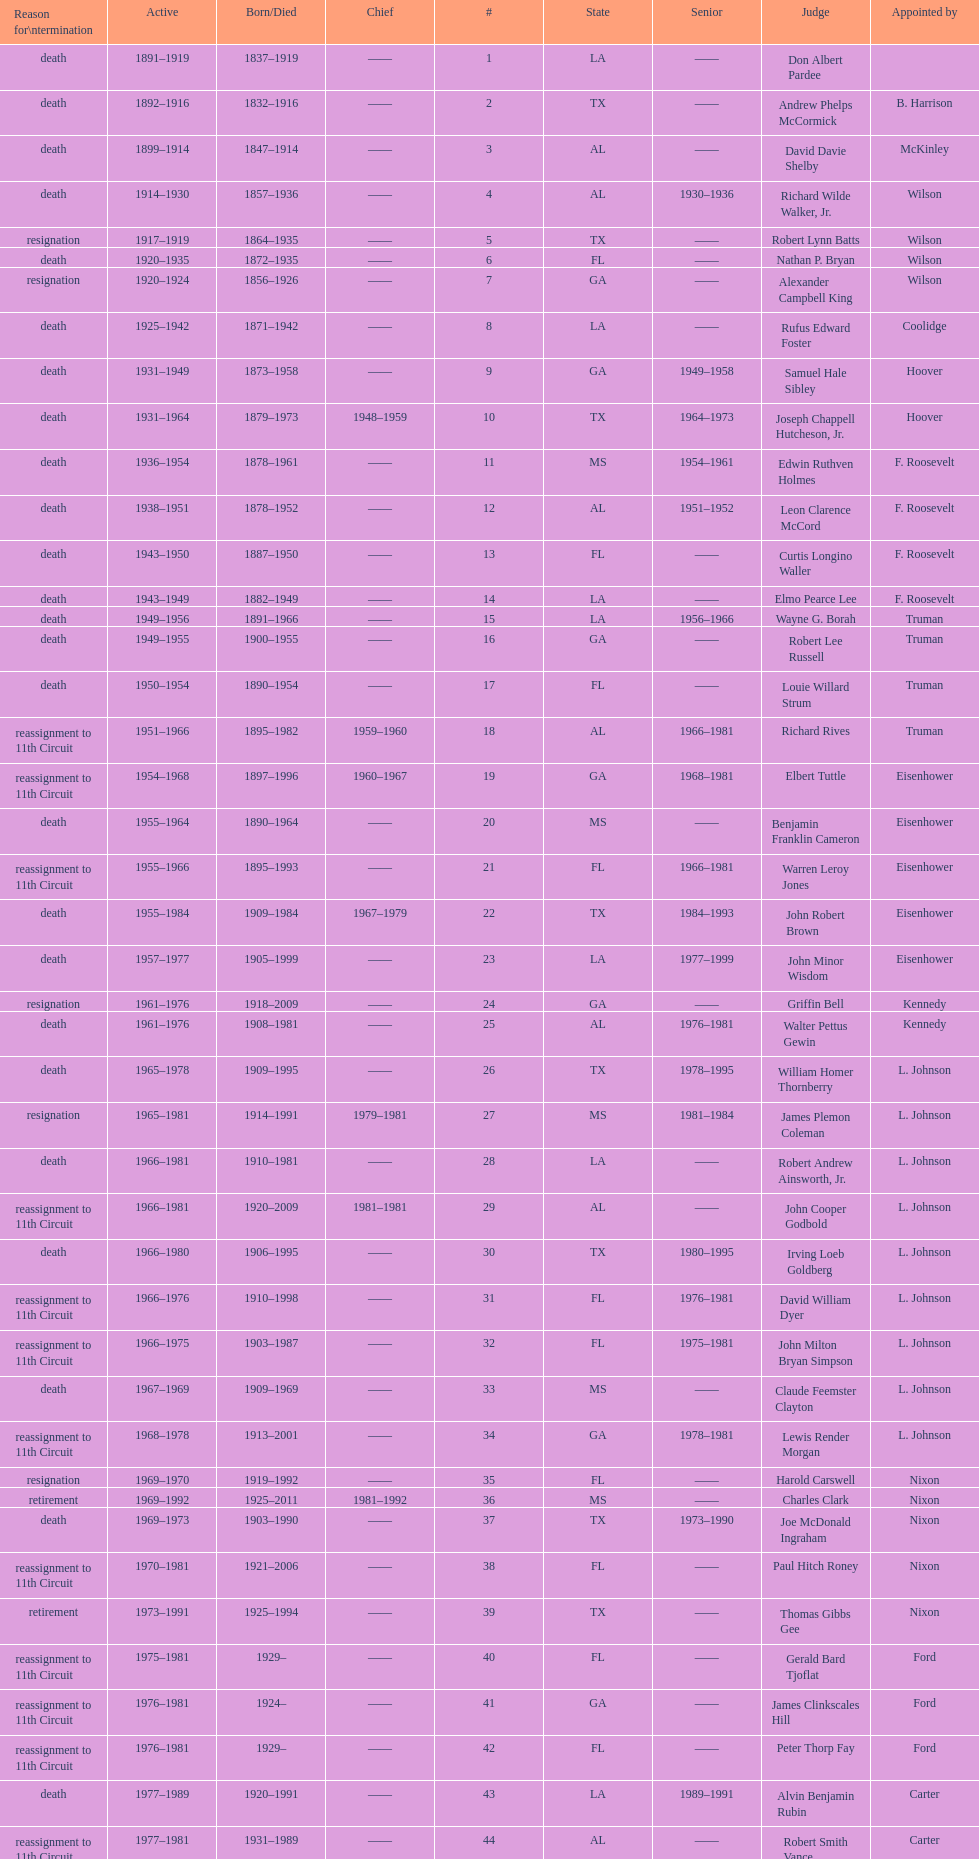Who was the first judge appointed from georgia? Alexander Campbell King. 